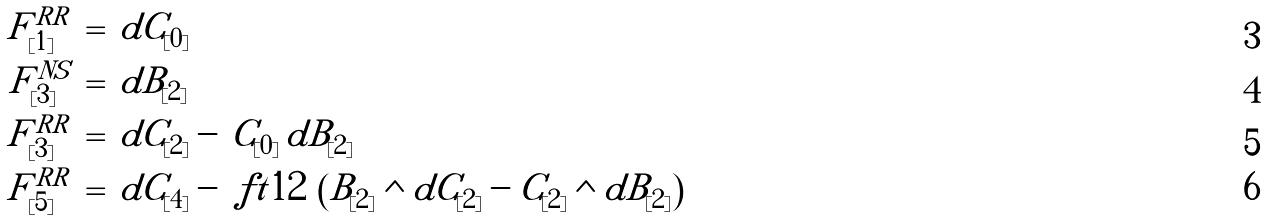<formula> <loc_0><loc_0><loc_500><loc_500>F ^ { R R } _ { [ 1 ] } & \, = \, d C _ { [ 0 ] } \\ F ^ { N S } _ { [ 3 ] } & \, = \, d B _ { [ 2 ] } \\ F ^ { R R } _ { [ 3 ] } & \, = \, d C _ { [ 2 ] } - \, C _ { [ 0 ] } \, d B _ { [ 2 ] } \\ F ^ { R R } _ { [ 5 ] } & \, = \, d C _ { [ 4 ] } - \ f t 1 2 \, \left ( B _ { [ 2 ] } \wedge d C _ { [ 2 ] } - C _ { [ 2 ] } \wedge d B _ { [ 2 ] } \right )</formula> 